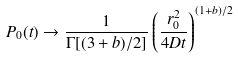<formula> <loc_0><loc_0><loc_500><loc_500>P _ { 0 } ( t ) \to \frac { 1 } { \Gamma [ ( 3 + b ) / 2 ] } \left ( \frac { r _ { 0 } ^ { 2 } } { 4 D t } \right ) ^ { ( 1 + b ) / 2 }</formula> 